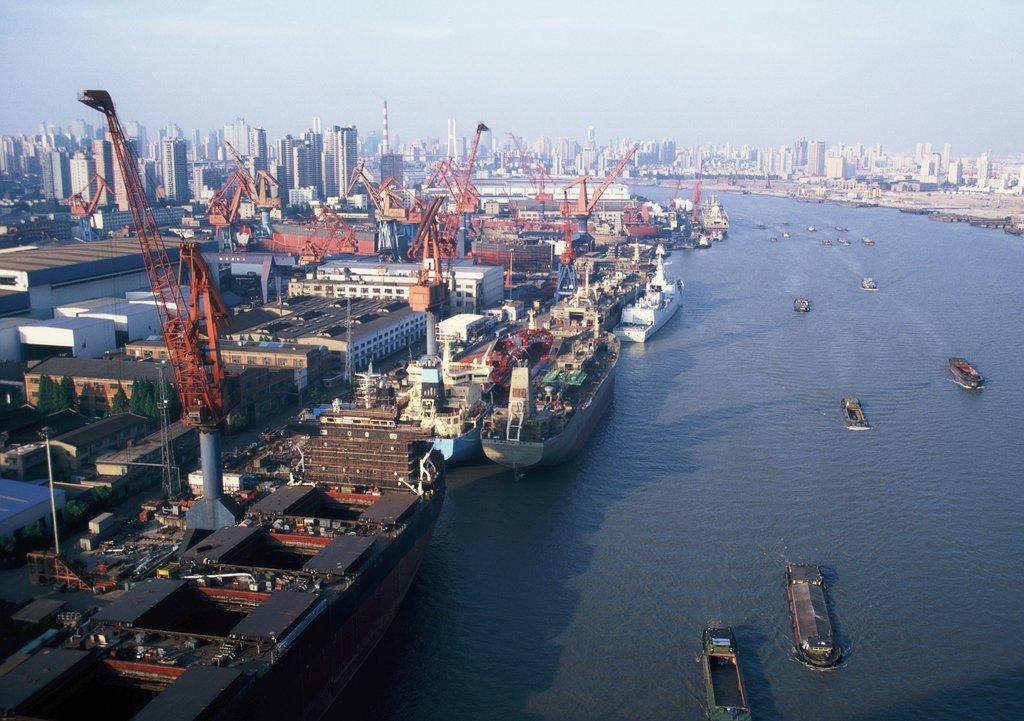Describe this image in one or two sentences. In this image we can see a few boats on the water, there are some buildings, cranes and trees, in the background we can see the sky. 